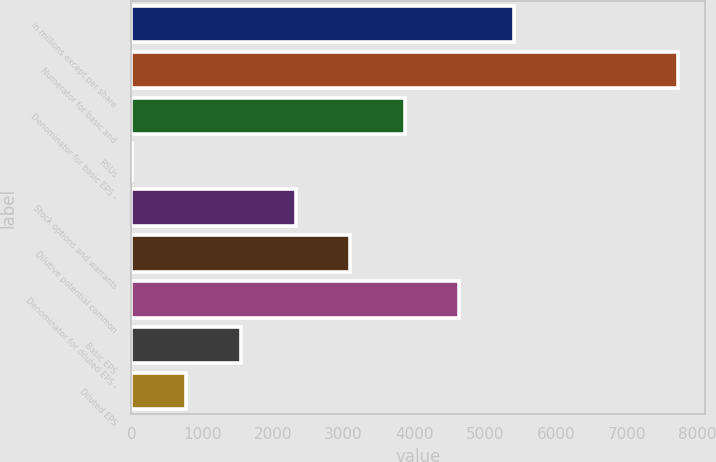Convert chart to OTSL. <chart><loc_0><loc_0><loc_500><loc_500><bar_chart><fcel>in millions except per share<fcel>Numerator for basic and<fcel>Denominator for basic EPS -<fcel>RSUs<fcel>Stock options and warrants<fcel>Dilutive potential common<fcel>Denominator for diluted EPS -<fcel>Basic EPS<fcel>Diluted EPS<nl><fcel>5410.36<fcel>7726<fcel>3866.6<fcel>7.2<fcel>2322.84<fcel>3094.72<fcel>4638.48<fcel>1550.96<fcel>779.08<nl></chart> 